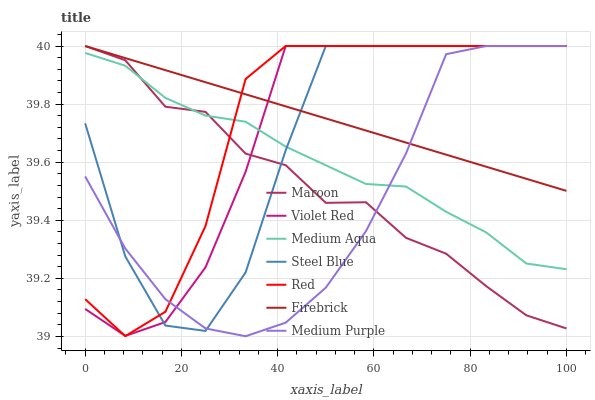Does Medium Purple have the minimum area under the curve?
Answer yes or no. Yes. Does Firebrick have the maximum area under the curve?
Answer yes or no. Yes. Does Steel Blue have the minimum area under the curve?
Answer yes or no. No. Does Steel Blue have the maximum area under the curve?
Answer yes or no. No. Is Firebrick the smoothest?
Answer yes or no. Yes. Is Steel Blue the roughest?
Answer yes or no. Yes. Is Steel Blue the smoothest?
Answer yes or no. No. Is Firebrick the roughest?
Answer yes or no. No. Does Medium Purple have the lowest value?
Answer yes or no. Yes. Does Steel Blue have the lowest value?
Answer yes or no. No. Does Red have the highest value?
Answer yes or no. Yes. Does Medium Aqua have the highest value?
Answer yes or no. No. Is Medium Aqua less than Firebrick?
Answer yes or no. Yes. Is Firebrick greater than Medium Aqua?
Answer yes or no. Yes. Does Firebrick intersect Medium Purple?
Answer yes or no. Yes. Is Firebrick less than Medium Purple?
Answer yes or no. No. Is Firebrick greater than Medium Purple?
Answer yes or no. No. Does Medium Aqua intersect Firebrick?
Answer yes or no. No. 